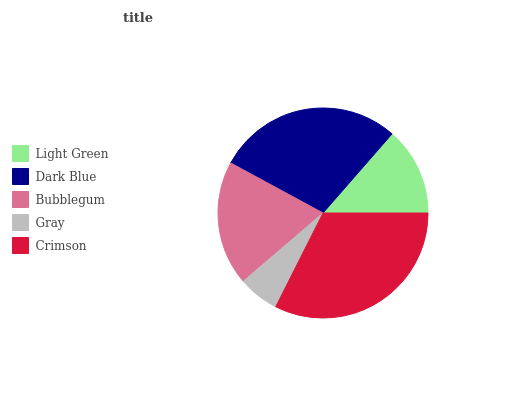Is Gray the minimum?
Answer yes or no. Yes. Is Crimson the maximum?
Answer yes or no. Yes. Is Dark Blue the minimum?
Answer yes or no. No. Is Dark Blue the maximum?
Answer yes or no. No. Is Dark Blue greater than Light Green?
Answer yes or no. Yes. Is Light Green less than Dark Blue?
Answer yes or no. Yes. Is Light Green greater than Dark Blue?
Answer yes or no. No. Is Dark Blue less than Light Green?
Answer yes or no. No. Is Bubblegum the high median?
Answer yes or no. Yes. Is Bubblegum the low median?
Answer yes or no. Yes. Is Crimson the high median?
Answer yes or no. No. Is Light Green the low median?
Answer yes or no. No. 